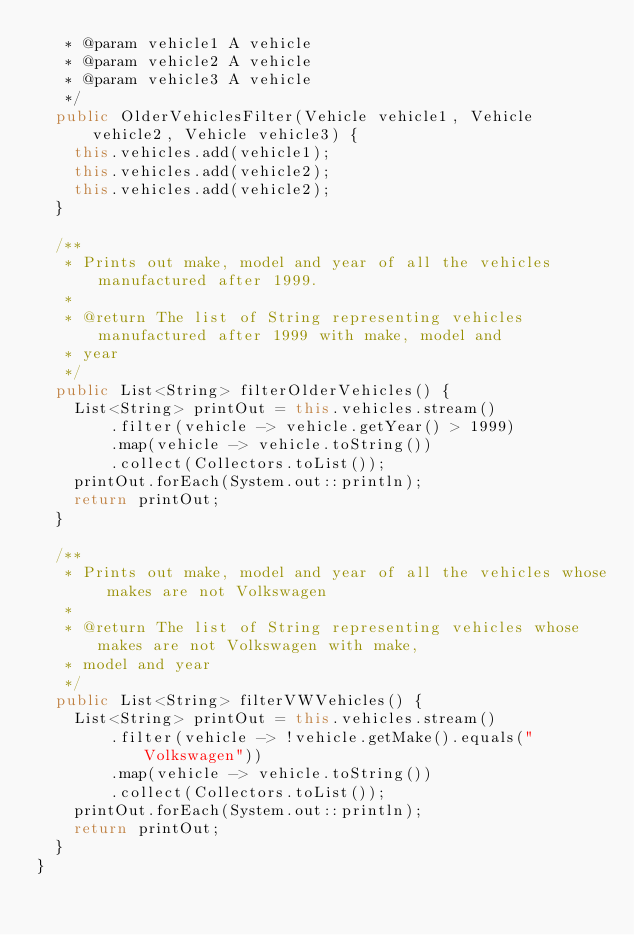Convert code to text. <code><loc_0><loc_0><loc_500><loc_500><_Java_>   * @param vehicle1 A vehicle
   * @param vehicle2 A vehicle
   * @param vehicle3 A vehicle
   */
  public OlderVehiclesFilter(Vehicle vehicle1, Vehicle
      vehicle2, Vehicle vehicle3) {
    this.vehicles.add(vehicle1);
    this.vehicles.add(vehicle2);
    this.vehicles.add(vehicle2);
  }

  /**
   * Prints out make, model and year of all the vehicles manufactured after 1999.
   *
   * @return The list of String representing vehicles manufactured after 1999 with make, model and
   * year
   */
  public List<String> filterOlderVehicles() {
    List<String> printOut = this.vehicles.stream()
        .filter(vehicle -> vehicle.getYear() > 1999)
        .map(vehicle -> vehicle.toString())
        .collect(Collectors.toList());
    printOut.forEach(System.out::println);
    return printOut;
  }

  /**
   * Prints out make, model and year of all the vehicles whose makes are not Volkswagen
   *
   * @return The list of String representing vehicles whose makes are not Volkswagen with make,
   * model and year
   */
  public List<String> filterVWVehicles() {
    List<String> printOut = this.vehicles.stream()
        .filter(vehicle -> !vehicle.getMake().equals("Volkswagen"))
        .map(vehicle -> vehicle.toString())
        .collect(Collectors.toList());
    printOut.forEach(System.out::println);
    return printOut;
  }
}
</code> 